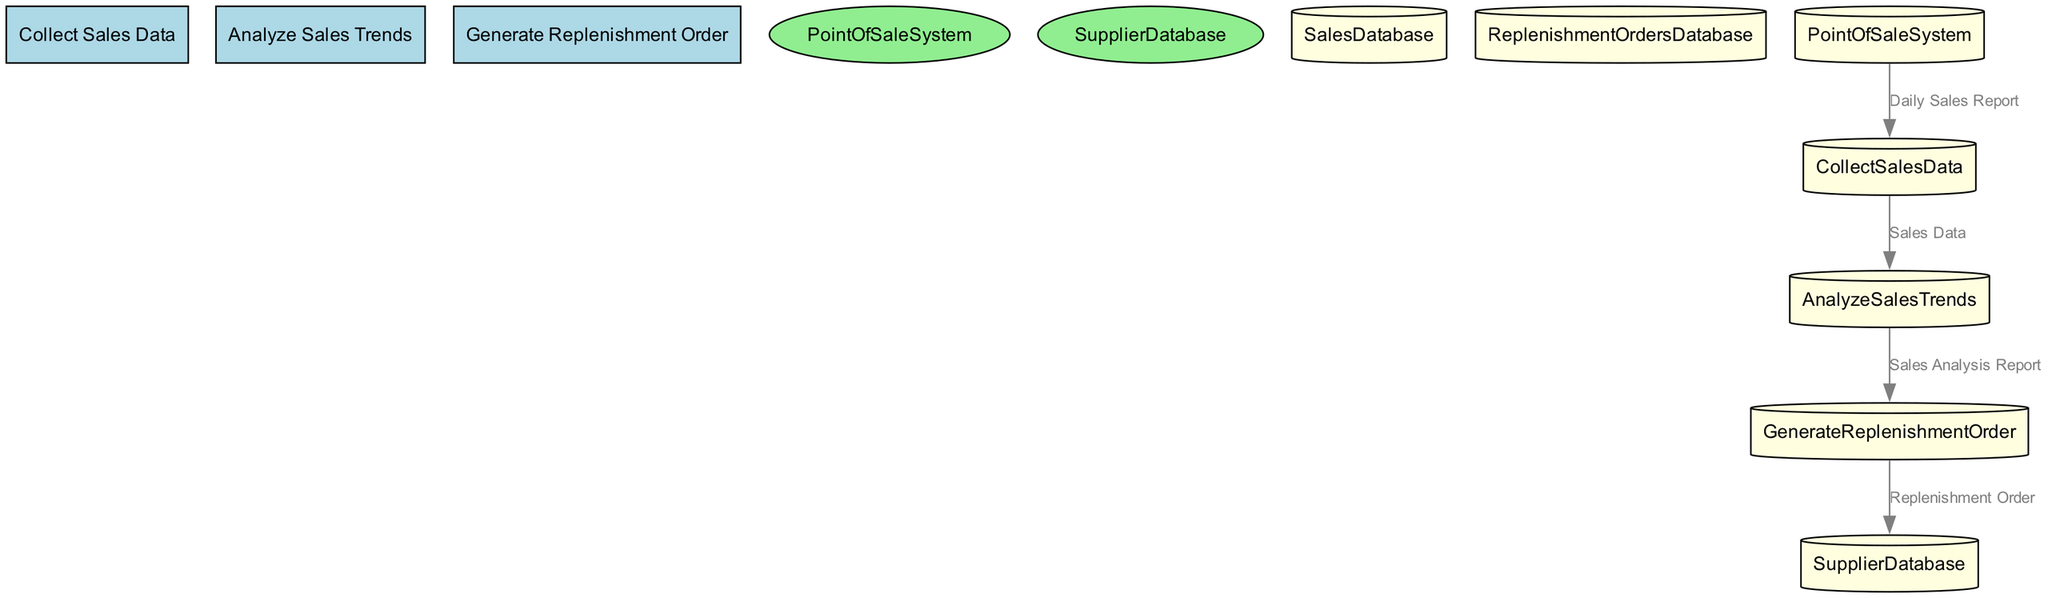What is the name of the first process? The first process in the diagram is labeled with the ID "P1," and its name is "Collect Sales Data."
Answer: Collect Sales Data How many data flows are there? The diagram includes four distinct data flows identified by the IDs "D1," "D2," "D3," and "D4."
Answer: 4 What entity provides the Daily Sales Report? The data flow labeled "Daily Sales Report" originates from the "PointOfSaleSystem" entity, which records sales transactions.
Answer: PointOfSaleSystem Which process generates the Replenishment Order? The diagram shows that the process responsible for creating replenishment orders is identified as "P3," which is named "Generate Replenishment Order."
Answer: Generate Replenishment Order What is the destination of the Sales Analysis Report? The "Sales Analysis Report" data flow is directed from the "Analyze Sales Trends" process to the "Generate Replenishment Order" process, indicating its destination.
Answer: Generate Replenishment Order Which data store is associated with storing historical sales data? The diagram shows that the "SalesDatabase" data store is specifically designated to store historical sales data, which is involved in the "Collect Sales Data" process.
Answer: SalesDatabase How many processes are there in total? The diagram features three processes: "Collect Sales Data," "Analyze Sales Trends," and "Generate Replenishment Order," summing up to a total of three.
Answer: 3 What type of database stores information about replenishment orders? The label for the data store associated with replenishment orders is "ReplenishmentOrdersDatabase," indicating its specific purpose and type.
Answer: ReplenishmentOrdersDatabase Which data flow comes from the Analyze Sales Trends process? The data flow that originates from the "Analyze Sales Trends" process is labeled as "Sales Analysis Report," which is crucial for creating replenishment orders.
Answer: Sales Analysis Report 